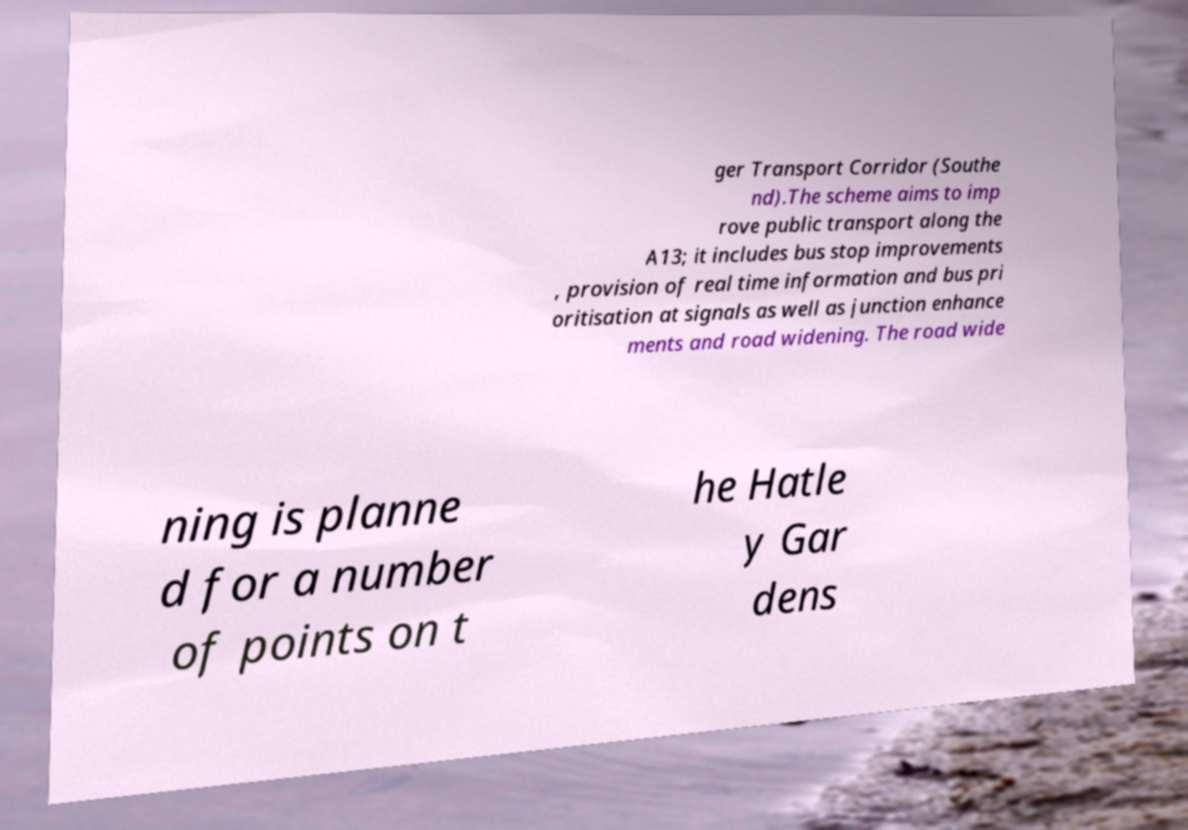I need the written content from this picture converted into text. Can you do that? ger Transport Corridor (Southe nd).The scheme aims to imp rove public transport along the A13; it includes bus stop improvements , provision of real time information and bus pri oritisation at signals as well as junction enhance ments and road widening. The road wide ning is planne d for a number of points on t he Hatle y Gar dens 